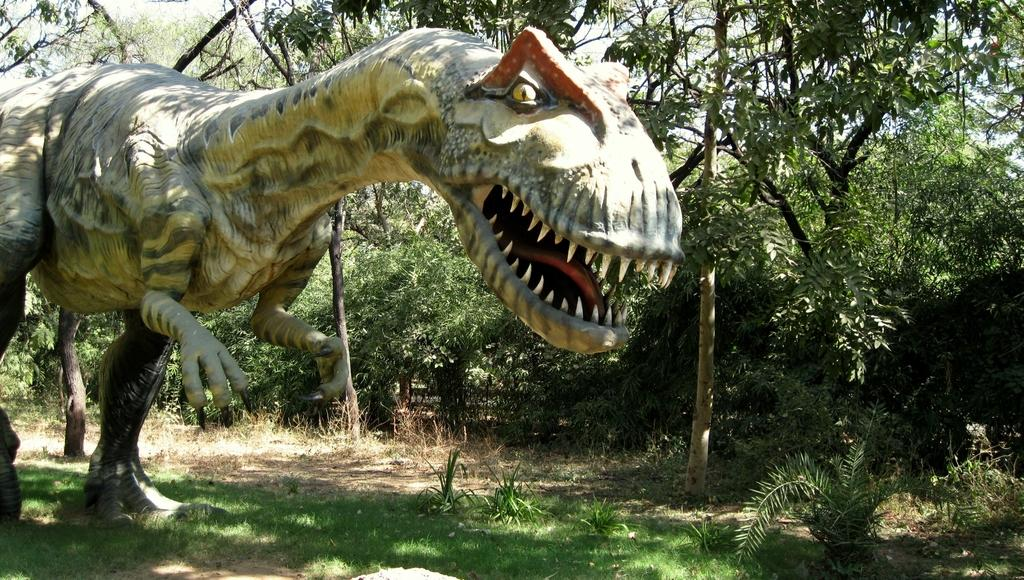What is the main subject of the image? There is a dragon statue in the image. How is the dragon statue positioned in the image? The dragon statue is standing on the ground. What type of surface is the dragon statue standing on? The ground is covered with grass. What can be seen in the background of the image? There are trees visible in the background of the image. Who is the owner of the pigs in the image? There are no pigs present in the image, so it is not possible to determine the owner. 